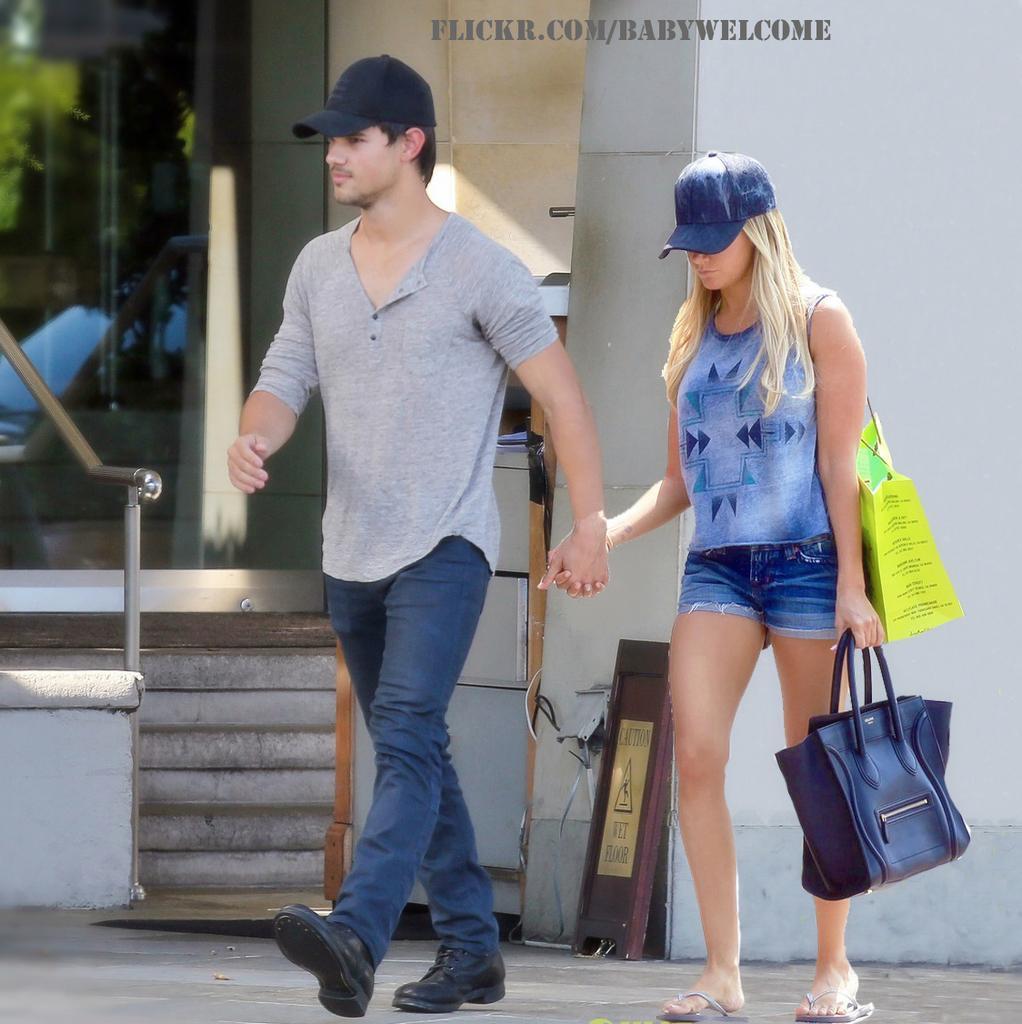Can you describe this image briefly? In the image two persons are walking. Behind them there is a building. 